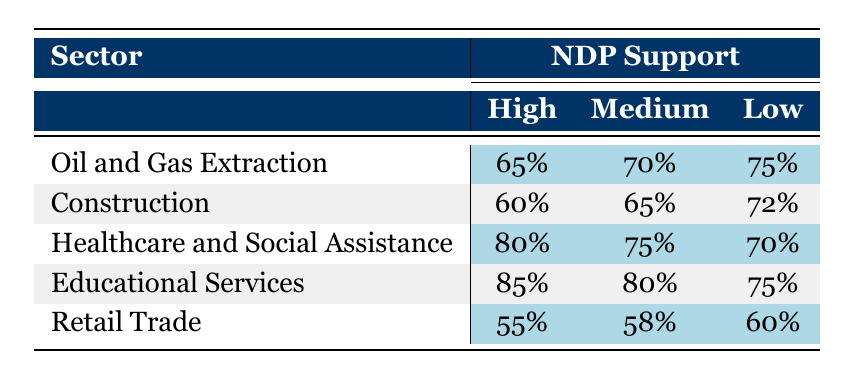What is the employment rate for the Oil and Gas Extraction sector with High NDP Support? According to the table, the employment rate for Oil and Gas Extraction when there is High NDP Support is 65%.
Answer: 65% What is the employment rate in Retail Trade with Medium NDP Support? The table indicates that the employment rate for Retail Trade with Medium NDP Support is 58%.
Answer: 58% Which sector has the highest employment rate under Low NDP Support? By examining the table, Educational Services has the highest employment rate of 75% under Low NDP Support.
Answer: Educational Services Is the employment rate in Healthcare and Social Assistance with High NDP Support greater than that in Construction with Medium NDP Support? The table shows 80% for Healthcare and Social Assistance with High NDP Support and 65% for Construction with Medium NDP Support. Since 80% is greater than 65%, the statement is true.
Answer: Yes What is the average employment rate across all sectors for Medium NDP Support? First, we sum the employment rates for Medium NDP Support: 70% (Oil and Gas) + 65% (Construction) + 75% (Healthcare) + 80% (Educational) + 58% (Retail) = 348%. There are 5 data points, so the average is 348% / 5 = 69.6%.
Answer: 69.6% Is it true that the employment rate for High NDP Support in the Retail Trade sector is lower than the employment rate for Low NDP Support in the same sector? The table lists the employment rate for High NDP Support in Retail Trade as 55% and for Low NDP Support as 60%. Since 55% is less than 60%, the statement is true.
Answer: Yes What is the difference in employment rates between Healthcare and Social Assistance and Retail Trade under High NDP Support? The employment rate for Healthcare and Social Assistance under High NDP Support is 80%, and for Retail Trade, it is 55%. The difference is 80% - 55% = 25%.
Answer: 25% Which sector shows the most significant decline in employment rates as NDP Support decreases from High to Low? To determine this, we look at the decline for each sector: Oil and Gas (10%), Construction (12%), Healthcare (10%), Educational Services (10%), and Retail Trade (5%). The largest decline is in Construction, with a decrease of 12%.
Answer: Construction What is the employment rate for Oil and Gas Extraction with Low NDP Support? The table indicates that the employment rate for Oil and Gas Extraction with Low NDP Support is 75%.
Answer: 75% 